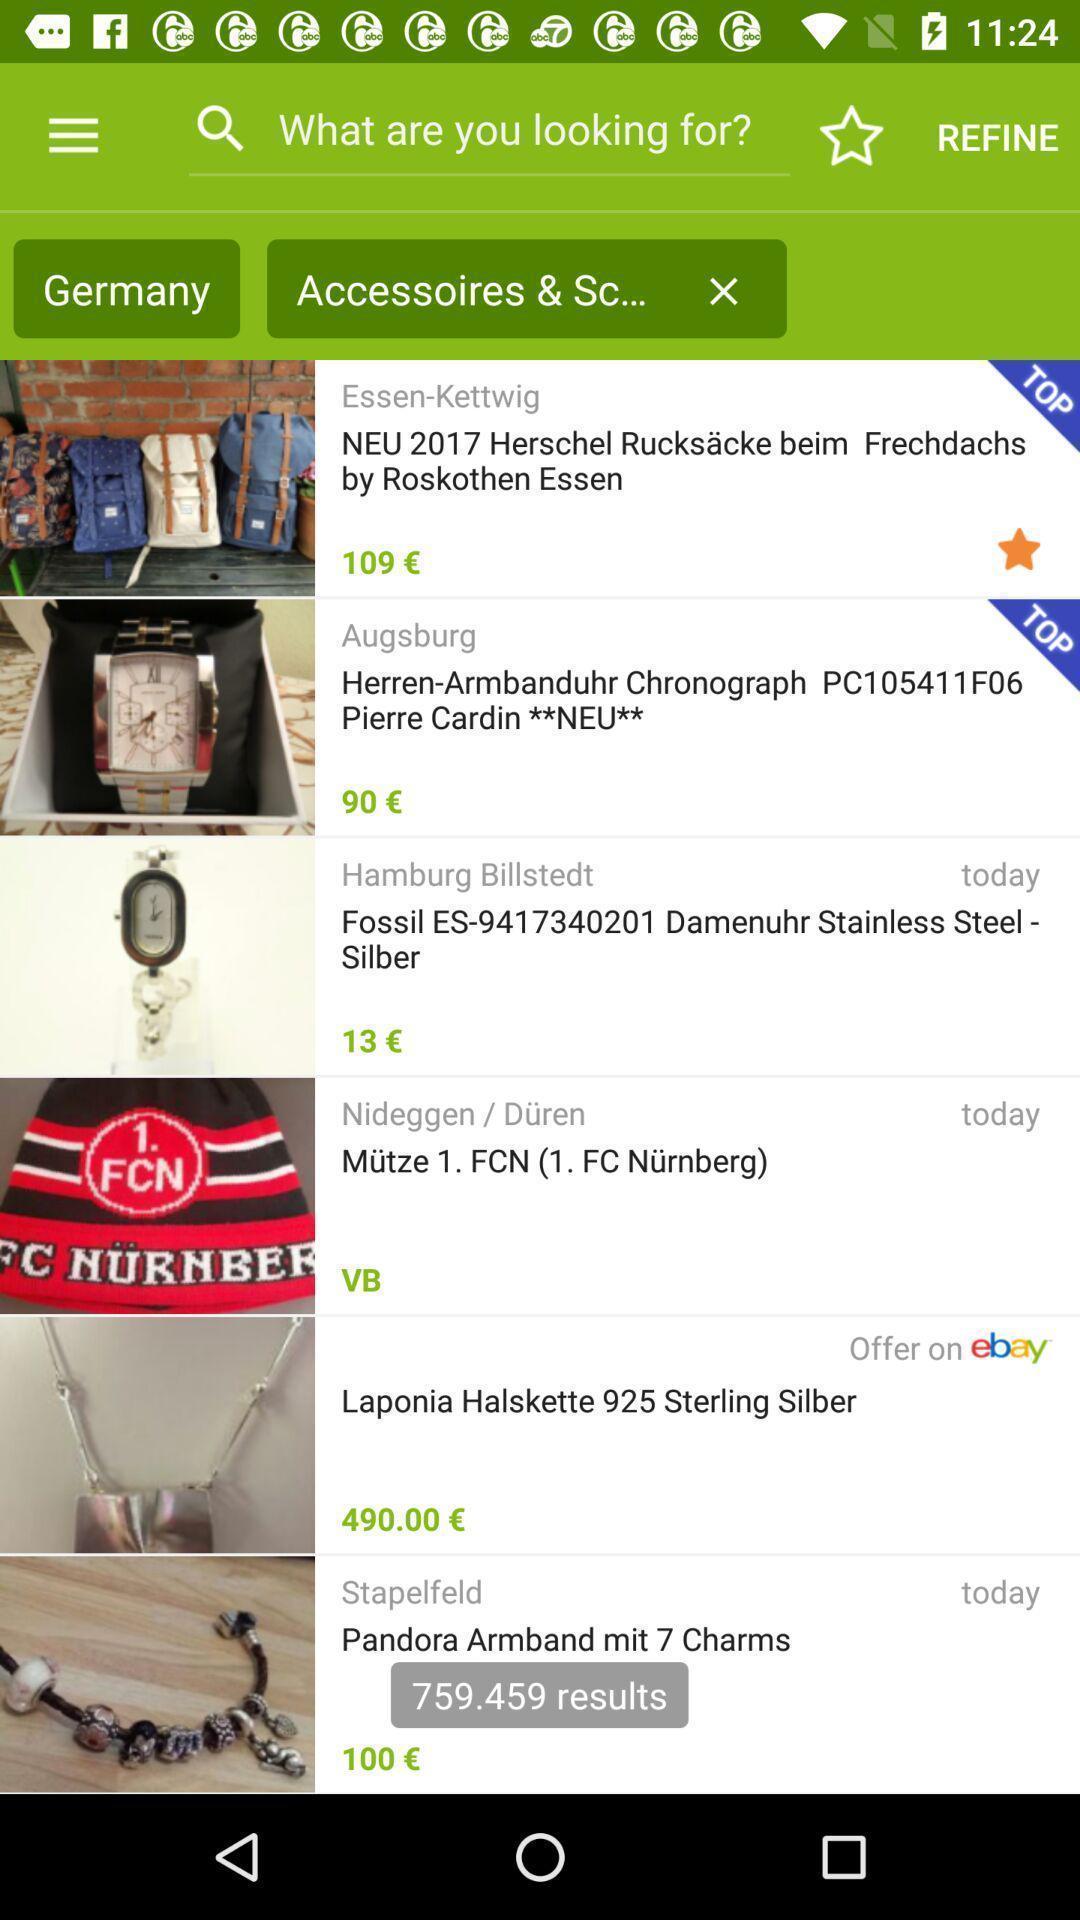Explain the elements present in this screenshot. Screen displaying the page of an online market app. 